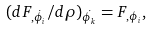<formula> <loc_0><loc_0><loc_500><loc_500>( d F _ { , \dot { \phi } _ { i } } / d \rho ) _ { \dot { \phi _ { k } } } = F _ { , \phi _ { i } } ,</formula> 